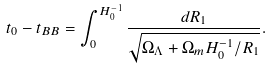Convert formula to latex. <formula><loc_0><loc_0><loc_500><loc_500>t _ { 0 } - t _ { B B } = \int ^ { H ^ { - 1 } _ { 0 } } _ { 0 } \frac { d R _ { 1 } } { \sqrt { \Omega _ { \Lambda } + \Omega _ { m } H ^ { - 1 } _ { 0 } / R _ { 1 } } } .</formula> 